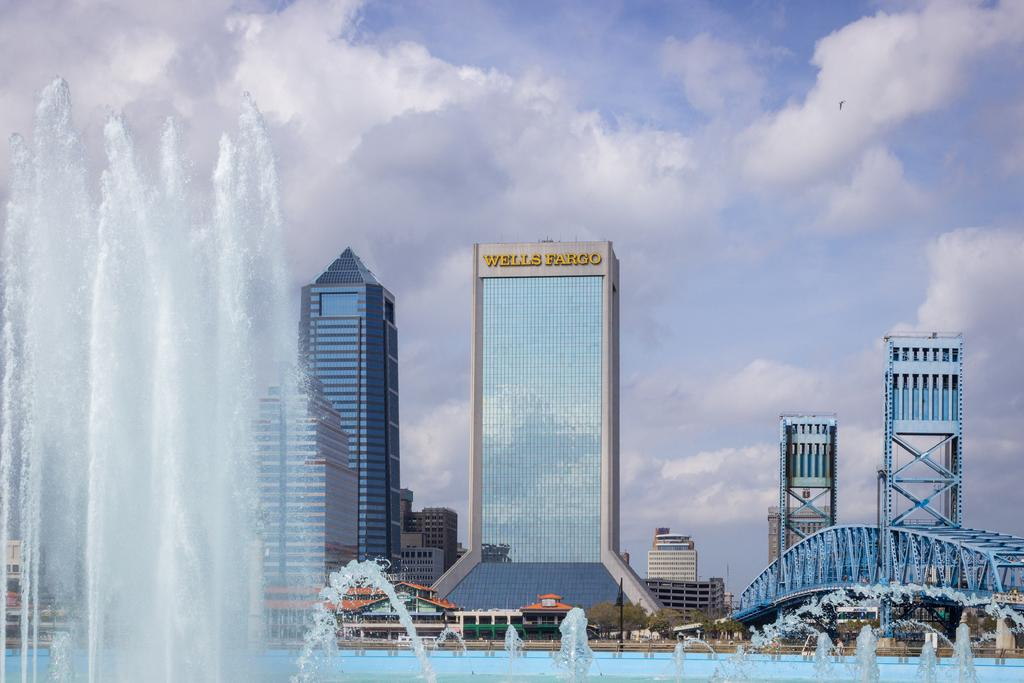What is the main feature in the image? There are water fountains in the image. What can be seen in the background of the image? There are buildings, trees, a bridge, a pole, and rods in the background of the image. How would you describe the sky in the image? The sky is cloudy in the background of the image. What type of watch can be seen hanging from the pole in the image? There is no watch present in the image, and the pole does not have anything hanging from it. What kind of bait is used to attract fish near the water fountains in the image? There is no mention of fish or bait in the image; it only features water fountains, buildings, trees, a bridge, a pole, and rods in the background. 